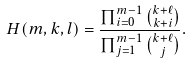<formula> <loc_0><loc_0><loc_500><loc_500>H ( m , k , l ) = \frac { \prod _ { i = 0 } ^ { m - 1 } \binom { k + \ell } { k + i } } { \prod _ { j = 1 } ^ { m - 1 } \binom { k + \ell } { j } } .</formula> 